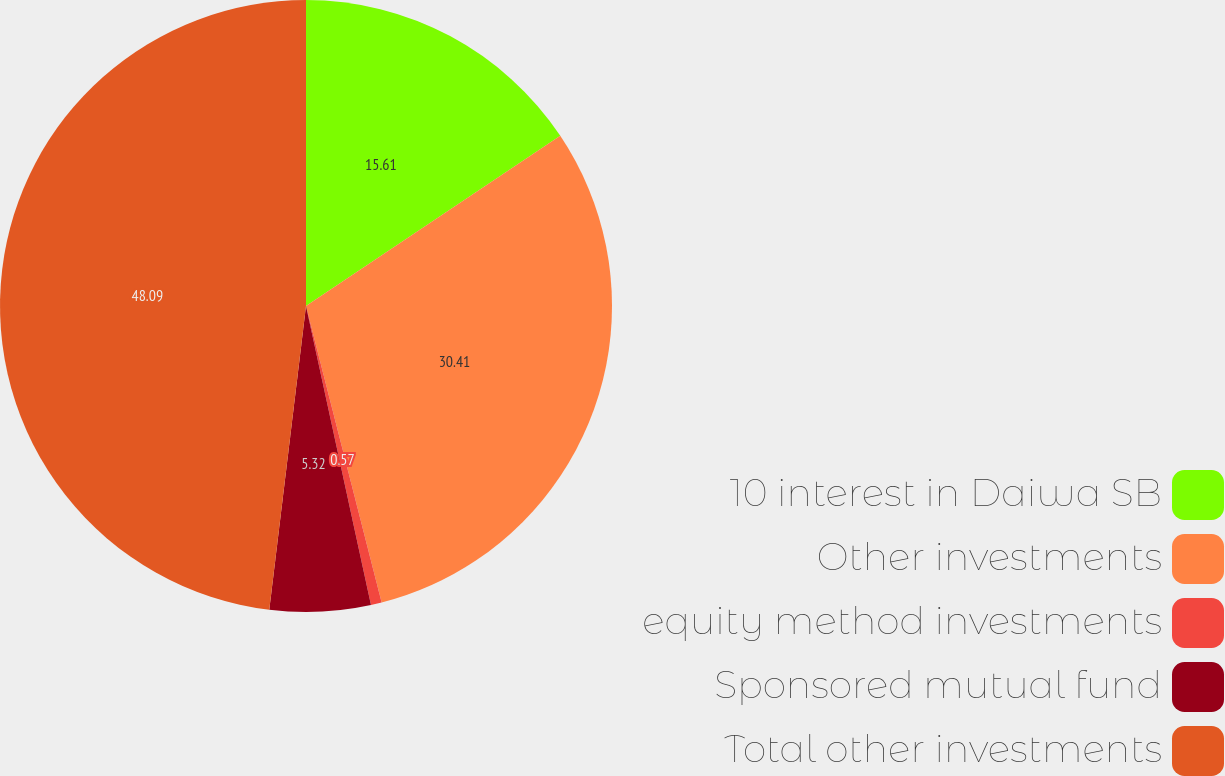<chart> <loc_0><loc_0><loc_500><loc_500><pie_chart><fcel>10 interest in Daiwa SB<fcel>Other investments<fcel>equity method investments<fcel>Sponsored mutual fund<fcel>Total other investments<nl><fcel>15.61%<fcel>30.41%<fcel>0.57%<fcel>5.32%<fcel>48.08%<nl></chart> 